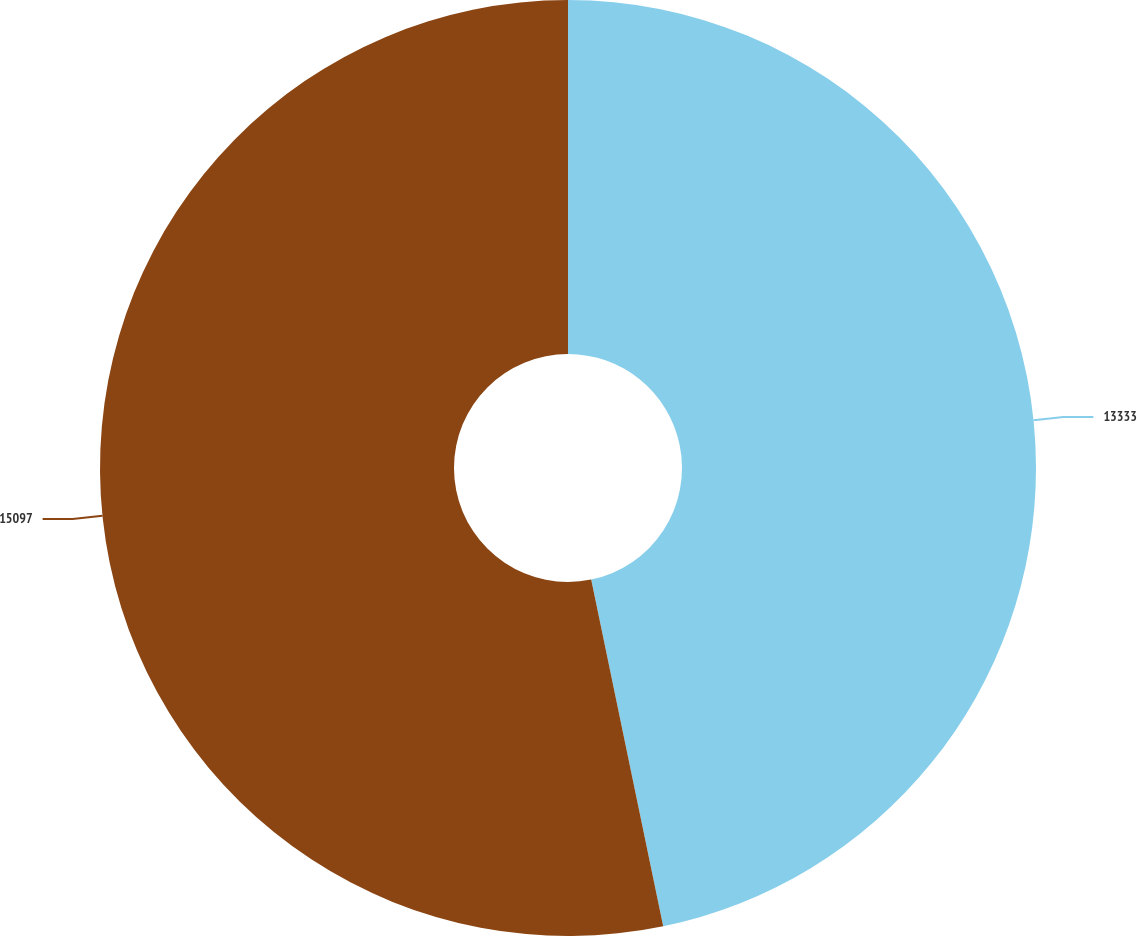Convert chart to OTSL. <chart><loc_0><loc_0><loc_500><loc_500><pie_chart><fcel>13333<fcel>15097<nl><fcel>46.74%<fcel>53.26%<nl></chart> 